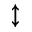Convert formula to latex. <formula><loc_0><loc_0><loc_500><loc_500>\updownarrow</formula> 